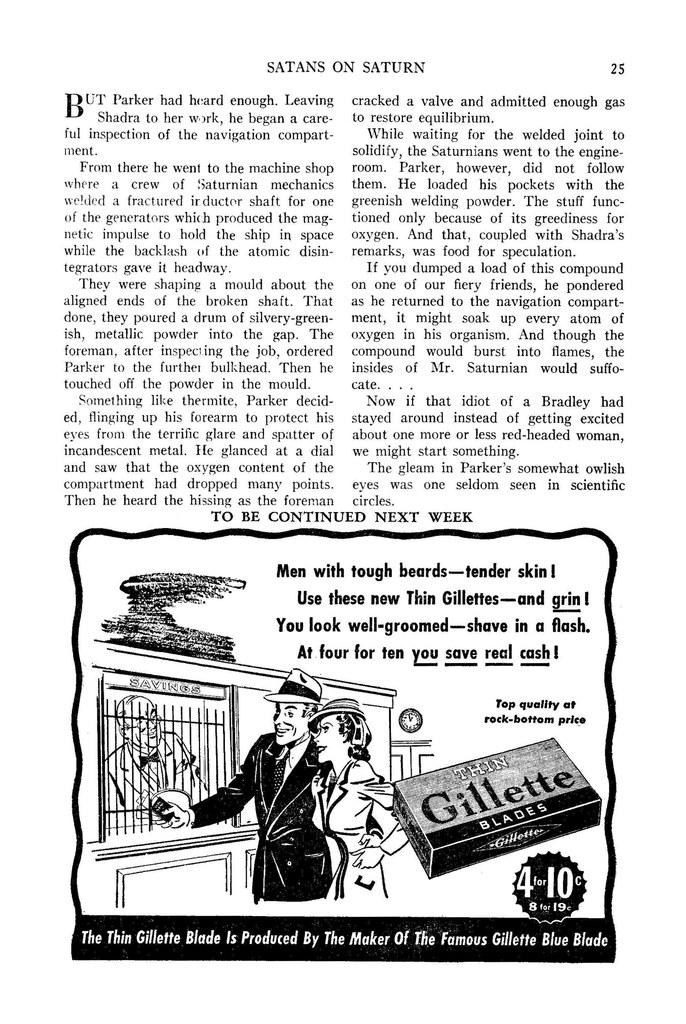What type of image is being described? The image appears to be a poster. What can be found on the poster besides images? There is text on the poster. Who or what can be seen on the poster? There are persons depicted on the poster. What type of structure is shown on the poster? There is a building shown on the poster. What other objects are present on the poster? A box and a clock are visible on the poster. Is there any text at the bottom of the image? Yes, there is text at the bottom of the image. What type of silk is being used by the worm in the image? There is no worm or silk present in the image. What kind of medical advice is the doctor giving in the image? There is no doctor present in the image. 